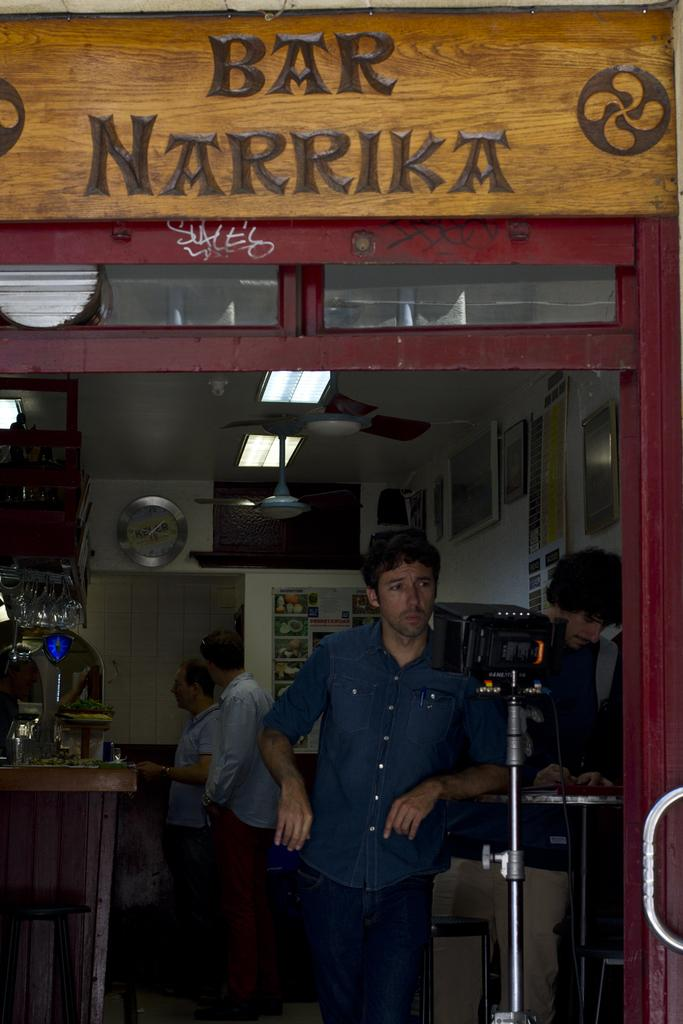Provide a one-sentence caption for the provided image. a storefront of Bar Narrika with a man leaning on the bar. 